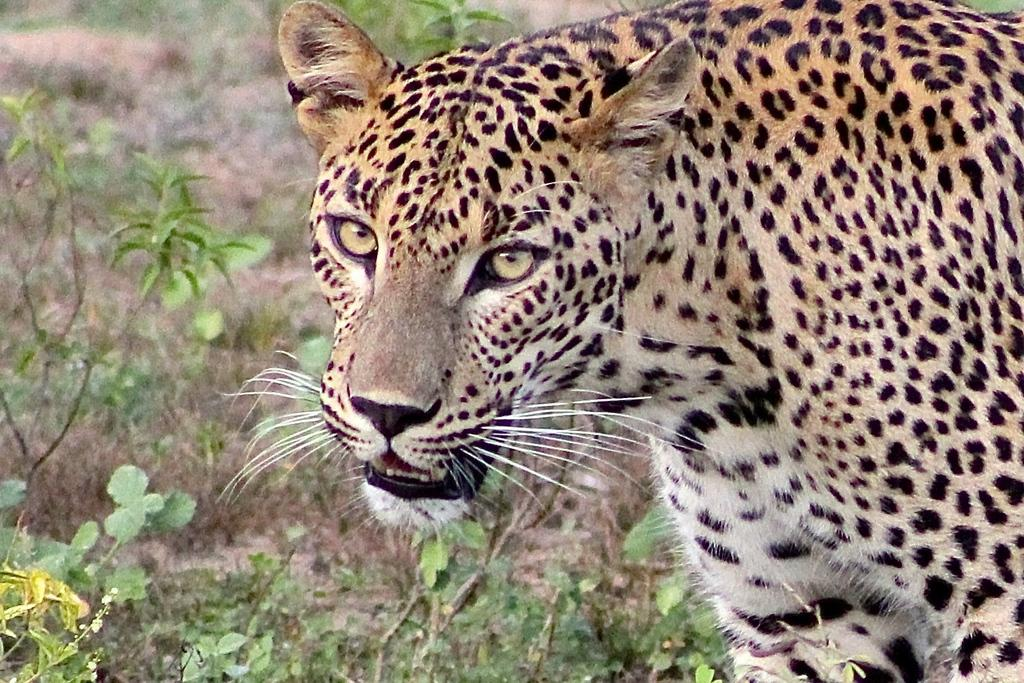What type of animal is on the right side of the image? There is a cheetah on the right side of the image. What can be seen at the bottom of the image? There are plants at the bottom of the image. What type of glue is being used by the cheetah in the image? There is no glue present in the image, and the cheetah is not using any glue. 